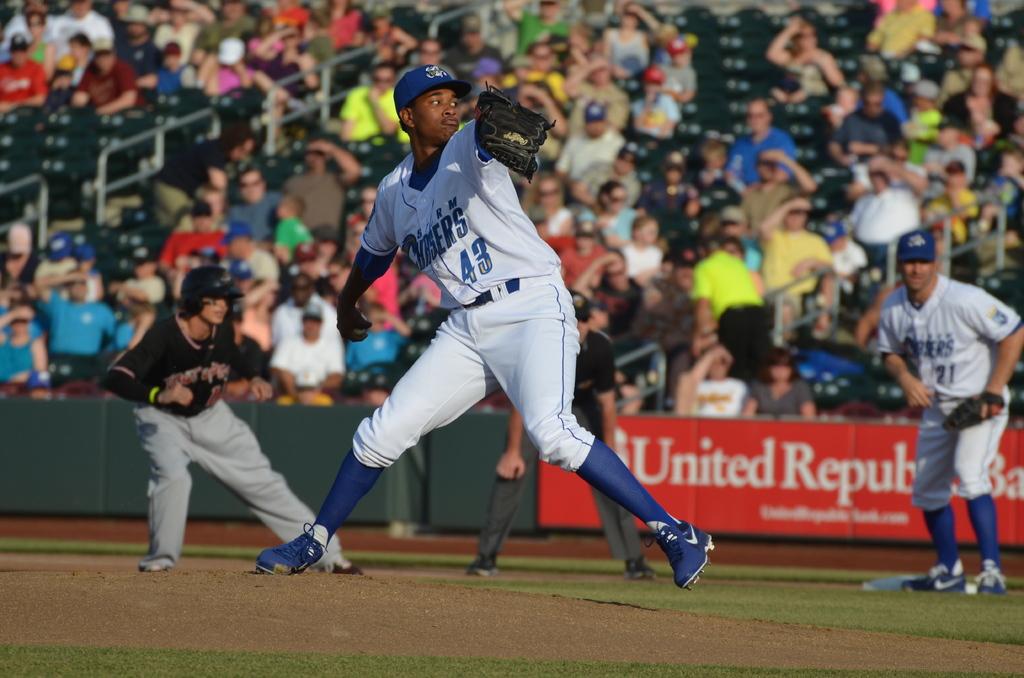What team is playing defense?
Your answer should be very brief. Storm chasers. What is the pitcher's number?
Your response must be concise. 43. 